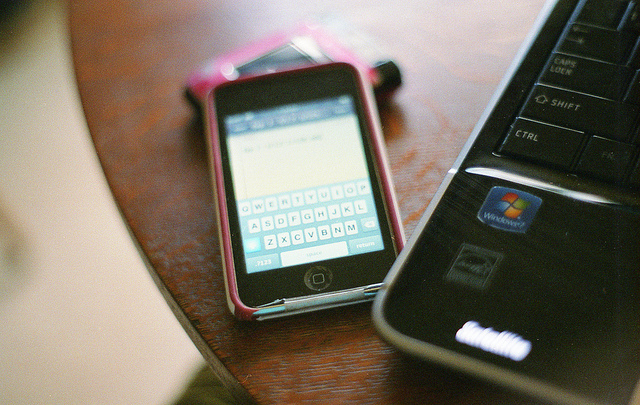<image>Who was this person texting? It is unknown who this person was texting. They could have been texting a friend, mom, husband, or someone named John. Who was this person texting? I don't know who this person was texting. It could be a friend, mom, husband, or John. 